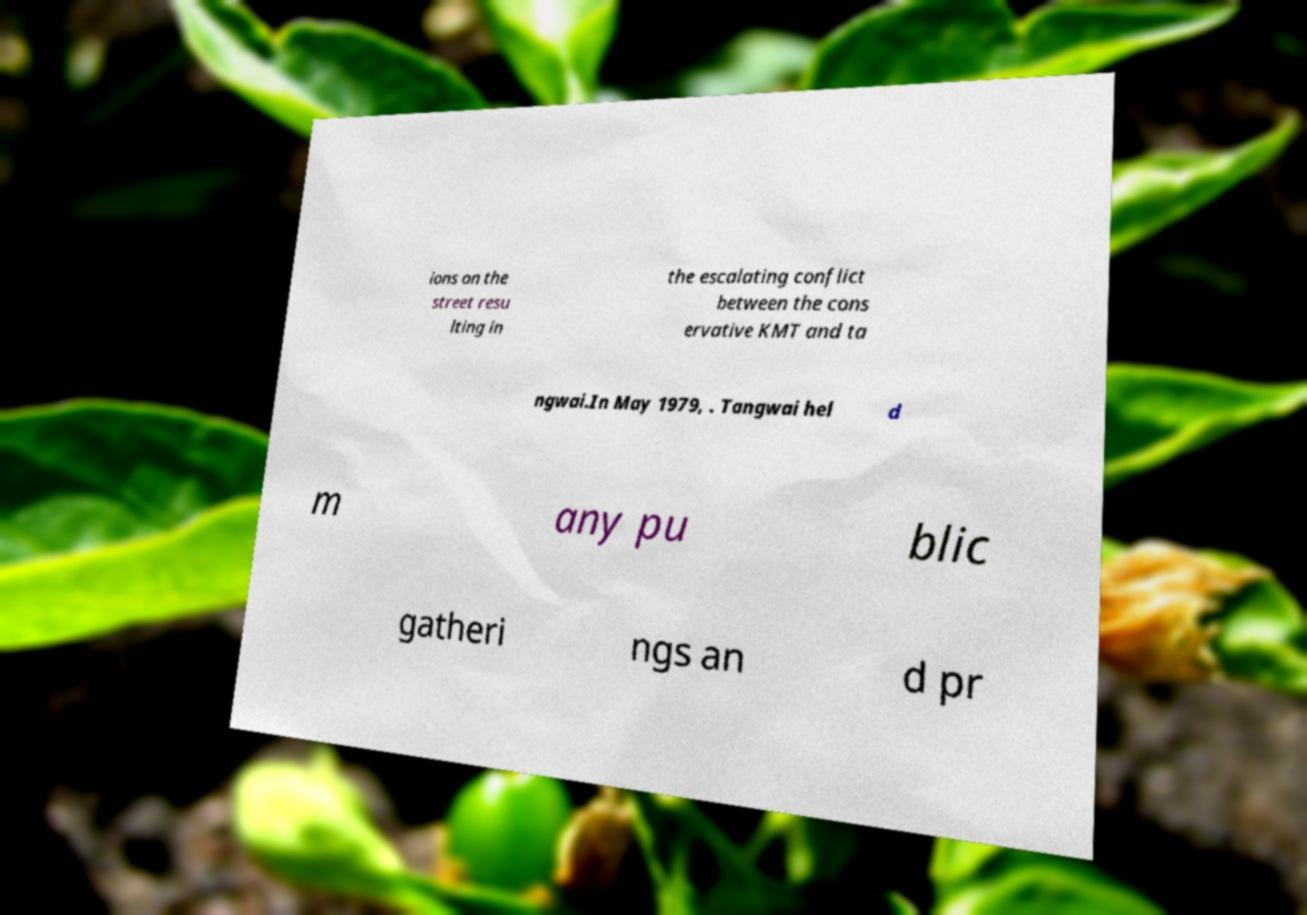There's text embedded in this image that I need extracted. Can you transcribe it verbatim? ions on the street resu lting in the escalating conflict between the cons ervative KMT and ta ngwai.In May 1979, . Tangwai hel d m any pu blic gatheri ngs an d pr 